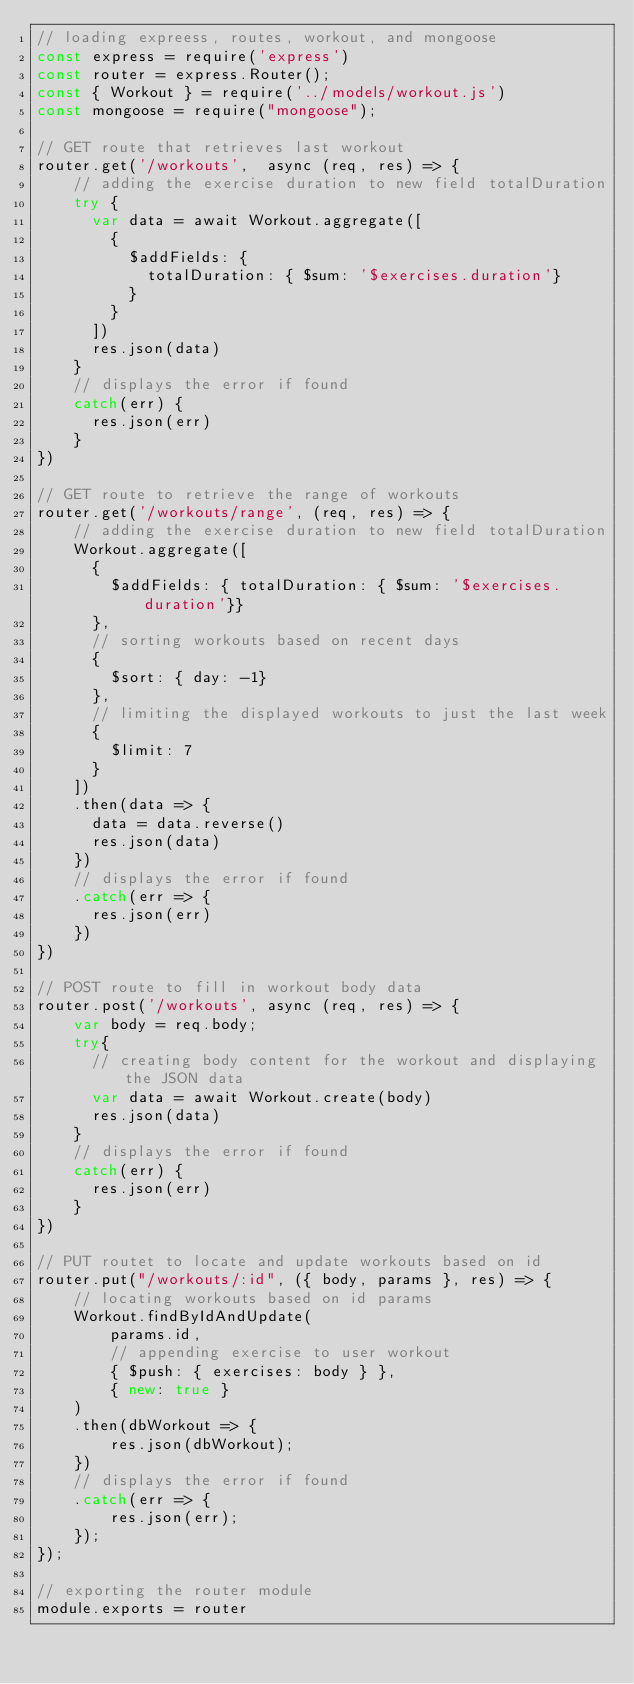<code> <loc_0><loc_0><loc_500><loc_500><_JavaScript_>// loading expreess, routes, workout, and mongoose
const express = require('express')
const router = express.Router();
const { Workout } = require('../models/workout.js')
const mongoose = require("mongoose");

// GET route that retrieves last workout
router.get('/workouts',  async (req, res) => {
    // adding the exercise duration to new field totalDuration
    try {
      var data = await Workout.aggregate([
        {
          $addFields: {
            totalDuration: { $sum: '$exercises.duration'}
          }
        }
      ])
      res.json(data)
    }
    // displays the error if found
    catch(err) {
      res.json(err)
    }
})

// GET route to retrieve the range of workouts
router.get('/workouts/range', (req, res) => {
    // adding the exercise duration to new field totalDuration
    Workout.aggregate([
      {
        $addFields: { totalDuration: { $sum: '$exercises.duration'}}
      },
      // sorting workouts based on recent days   
      {
        $sort: { day: -1}
      },
      // limiting the displayed workouts to just the last week  
      {
        $limit: 7
      }
    ])
    .then(data => {
      data = data.reverse()
      res.json(data)
    })
    // displays the error if found
    .catch(err => {
      res.json(err)
    })
})

// POST route to fill in workout body data
router.post('/workouts', async (req, res) => {
    var body = req.body;
    try{
      // creating body content for the workout and displaying the JSON data
      var data = await Workout.create(body)
      res.json(data)
    }
    // displays the error if found
    catch(err) {
      res.json(err)
    }
})

// PUT routet to locate and update workouts based on id
router.put("/workouts/:id", ({ body, params }, res) => {
    // locating workouts based on id params
    Workout.findByIdAndUpdate(
        params.id,
        // appending exercise to user workout
        { $push: { exercises: body } },
        { new: true }
    )
    .then(dbWorkout => {
        res.json(dbWorkout);
    })
    // displays the error if found
    .catch(err => {
        res.json(err);
    });
});
  
// exporting the router module
module.exports = router
</code> 